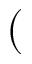<formula> <loc_0><loc_0><loc_500><loc_500>(</formula> 